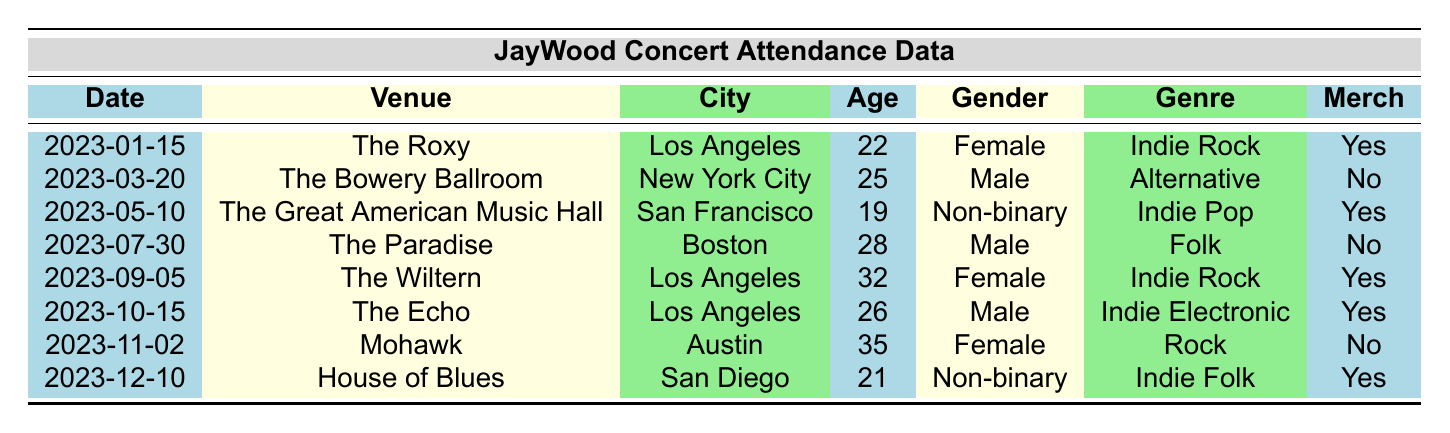What is the total number of concerts held in Los Angeles? By scanning the "City" column, I can identify that there are three entries for Los Angeles: on 2023-01-15, 2023-09-05, and 2023-10-15, which indicates that the total is 3 concerts.
Answer: 3 Which venue had the oldest attendee? The "Age" column shows the ages of attendees: 22, 25, 19, 28, 32, 26, 35, and 21. The highest age is 35. Referring to the "Age" value of 35, it corresponds to the entry under the "Mohawk" venue on 2023-11-02, so that is the venue for the oldest attendee.
Answer: Mohawk How many attendees preferred Indie Rock? Looking through the "prefers_genre" column, I can see that there are two instances where the preferred genre is "Indie Rock," specifically for the concerts on 2023-01-15 and 2023-09-05. Therefore, the total number of attendees who preferred Indie Rock is 2.
Answer: 2 Is there any non-binary attendee who purchased merchandise? By reviewing the "has_merchandise" column alongside the "gender" column, I find two non-binary attendees on 2023-05-10 and 2023-12-10. Both of them have merchandise indicated by a "Yes," thus confirming that there are non-binary attendees who purchased merchandise.
Answer: Yes What is the average age of attendees across all concerts? To find the average age, I first sum all the ages: 22 + 25 + 19 + 28 + 32 + 26 + 35 + 21 = 208. There are 8 attendees, so I divide the total age by the number of attendees: 208 / 8 = 26. Therefore, the average age of attendees is 26.
Answer: 26 How many attendees didn't buy merchandise? Counting the "has_merchandise" column, I see that four attendees have "No" under that category: 2023-03-20, 2023-07-30, and 2023-11-02. Thus, the total number of attendees who didn't buy merchandise is 3.
Answer: 3 Which concert had attendees preferring the genre "Alternative"? Referring to the "prefers_genre" column, the genre "Alternative" appears only once, which is associated with the concert data from 2023-03-20 at The Bowery Ballroom. Therefore, that concert is associated with attendees preferring "Alternative."
Answer: The Bowery Ballroom How many concerts featured male attendees? By checking the "gender" column, I find that there are four male entries from the concerts held on 2023-03-20, 2023-07-30, 2023-10-15. Consequently, the number of concerts with male attendees is 3.
Answer: 3 